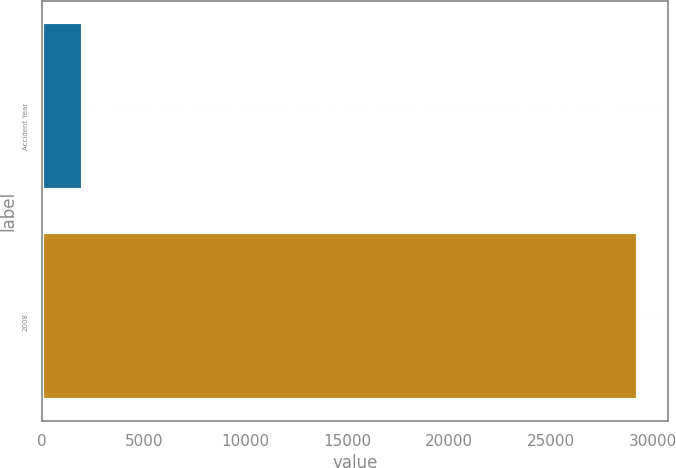Convert chart. <chart><loc_0><loc_0><loc_500><loc_500><bar_chart><fcel>Accident Year<fcel>2008<nl><fcel>2009<fcel>29300<nl></chart> 